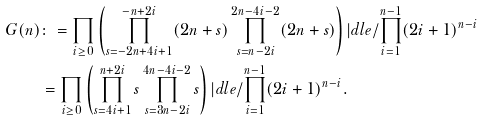Convert formula to latex. <formula><loc_0><loc_0><loc_500><loc_500>G ( n ) & \colon = \prod _ { i \geq 0 } \left ( \prod _ { s = - 2 n + 4 i + 1 } ^ { - n + 2 i } ( 2 n + s ) \prod _ { s = n - 2 i } ^ { 2 n - 4 i - 2 } ( 2 n + s ) \right ) | d l e / \prod _ { i = 1 } ^ { n - 1 } ( 2 i + 1 ) ^ { n - i } \\ & = \prod _ { i \geq 0 } \left ( \prod _ { s = 4 i + 1 } ^ { n + 2 i } s \prod _ { s = 3 n - 2 i } ^ { 4 n - 4 i - 2 } s \right ) | d l e / \prod _ { i = 1 } ^ { n - 1 } ( 2 i + 1 ) ^ { n - i } .</formula> 